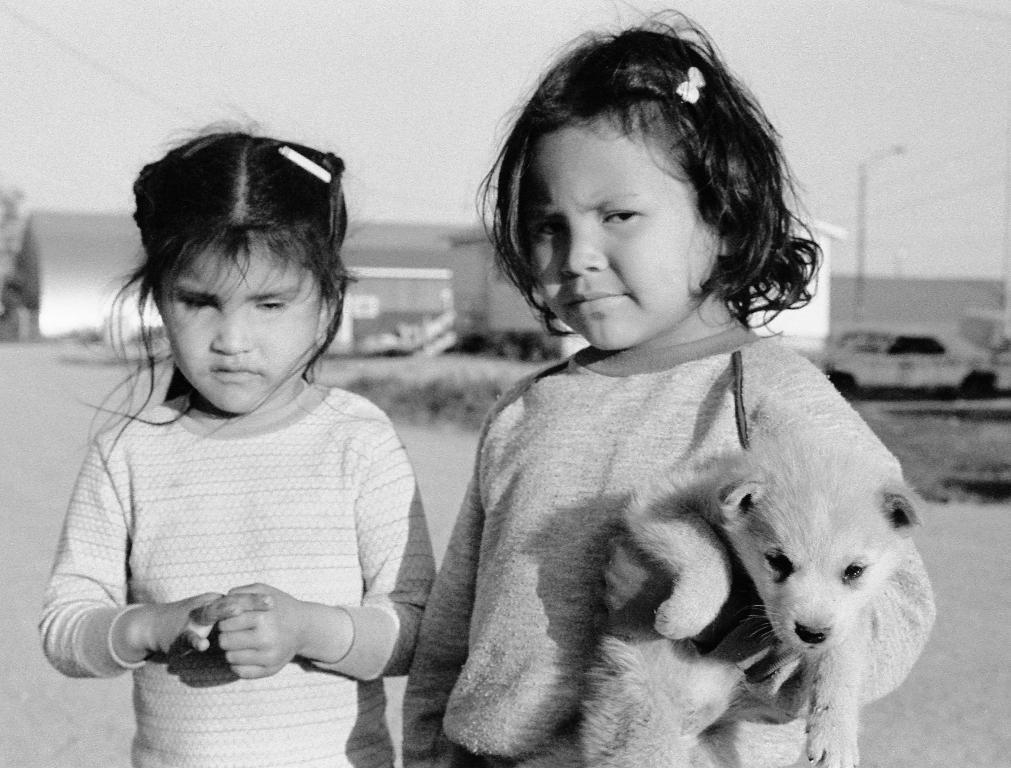How many girls are in the image? There are two girls in the image. What is one of the girls doing with an animal? One of the girls is holding a dog. What can be seen in the background of the image? There is a car, a tree, and buildings in the background of the image. What type of frog can be seen resting on the hammer in the image? There is no frog or hammer present in the image. 